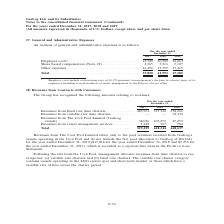From Gaslog's financial document, What are the components of the revenues? The document contains multiple relevant values: Revenues from fixed rate time charters, Revenues from variable rate time charters, Revenues from The Cool Pool Limited (GasLog vessels), Revenues from vessel management services. From the document: "Revenues from fixed rate time charters . 485,961 515,324 558,266 Revenues from variable rate time charters . — — 64,334 Revenues from The nues from va..." Also, What are the two segments the management allocated the revenues from time charters? (a) variable rate charters and (b) fixed rate charters.. The document states: "tes revenues from time charters to two categories: (a) variable rate charters and (b) fixed rate charters. The variable rate charter category contains..." Also, What does the revenues from The Cool Pool Limited represent? Revenues from The Cool Pool Limited relate only to the pool revenues received from GasLog’s vessels operating in the Cool Pool. The document states: "Revenues from The Cool Pool Limited relate only to the pool revenues received from GasLog’s vessels operating in the Cool Pool and do not include the ..." Additionally, In which year was the revenues from fixed rate time charters the highest? According to the financial document, 2019. The relevant text states: "For the year ended December 31, 2017 2018 2019..." Also, can you calculate: What was the change in revenues from The Cool Pool Limited  from 2017 to 2018? Based on the calculation: 102,253 - 38,046 , the result is 64207 (in thousands). This is based on the information: "m The Cool Pool Limited (GasLog vessels) . 38,046 102,253 45,253 Revenues from vessel management services . 1,222 767 784 Total . 525,229 618,344 668,637 ues from The Cool Pool Limited (GasLog vessels..." The key data points involved are: 102,253, 38,046. Also, can you calculate: What was the percentage change in total revenue from 2018 to 2019? To answer this question, I need to perform calculations using the financial data. The calculation is: (668,637 - 618,344)/618,344 , which equals 8.13 (percentage). This is based on the information: "services . 1,222 767 784 Total . 525,229 618,344 668,637 nagement services . 1,222 767 784 Total . 525,229 618,344 668,637..." The key data points involved are: 618,344, 668,637. 